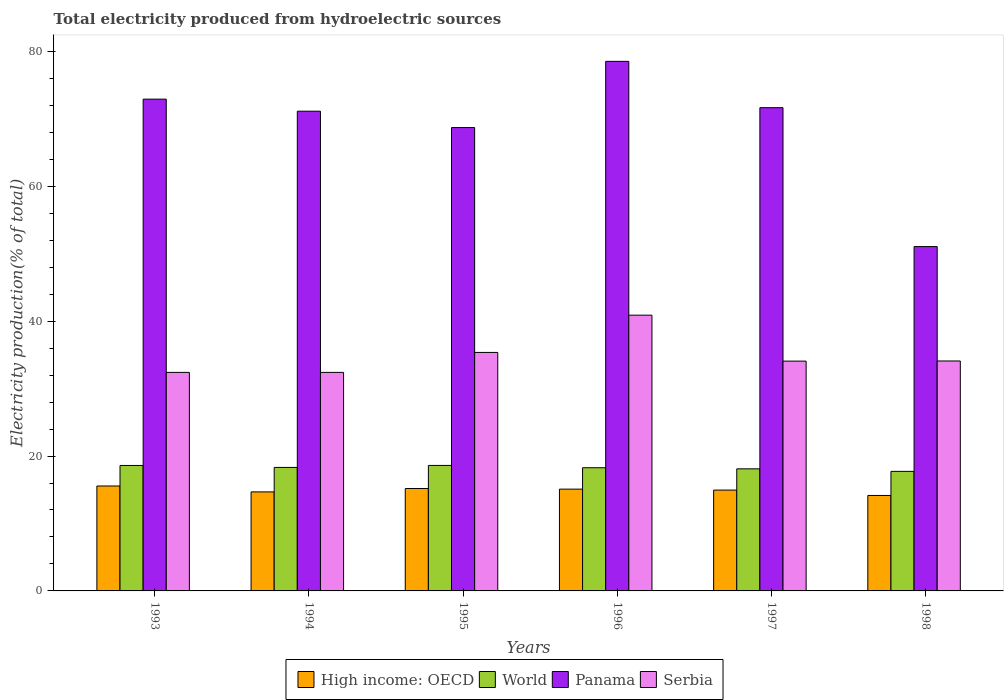How many different coloured bars are there?
Offer a terse response. 4. How many groups of bars are there?
Provide a short and direct response. 6. Are the number of bars per tick equal to the number of legend labels?
Offer a very short reply. Yes. Are the number of bars on each tick of the X-axis equal?
Provide a succinct answer. Yes. What is the label of the 2nd group of bars from the left?
Give a very brief answer. 1994. In how many cases, is the number of bars for a given year not equal to the number of legend labels?
Your response must be concise. 0. What is the total electricity produced in High income: OECD in 1995?
Keep it short and to the point. 15.19. Across all years, what is the maximum total electricity produced in World?
Make the answer very short. 18.61. Across all years, what is the minimum total electricity produced in Panama?
Offer a terse response. 51.06. In which year was the total electricity produced in High income: OECD maximum?
Make the answer very short. 1993. What is the total total electricity produced in World in the graph?
Give a very brief answer. 109.63. What is the difference between the total electricity produced in Panama in 1995 and that in 1996?
Make the answer very short. -9.82. What is the difference between the total electricity produced in Panama in 1993 and the total electricity produced in World in 1998?
Provide a short and direct response. 55.2. What is the average total electricity produced in Serbia per year?
Make the answer very short. 34.88. In the year 1997, what is the difference between the total electricity produced in Panama and total electricity produced in World?
Keep it short and to the point. 53.56. What is the ratio of the total electricity produced in World in 1996 to that in 1997?
Keep it short and to the point. 1.01. What is the difference between the highest and the second highest total electricity produced in High income: OECD?
Keep it short and to the point. 0.37. What is the difference between the highest and the lowest total electricity produced in Serbia?
Offer a terse response. 8.48. What does the 4th bar from the left in 1994 represents?
Make the answer very short. Serbia. Are all the bars in the graph horizontal?
Offer a very short reply. No. What is the difference between two consecutive major ticks on the Y-axis?
Provide a succinct answer. 20. Are the values on the major ticks of Y-axis written in scientific E-notation?
Keep it short and to the point. No. Does the graph contain grids?
Keep it short and to the point. No. Where does the legend appear in the graph?
Offer a very short reply. Bottom center. How many legend labels are there?
Your response must be concise. 4. What is the title of the graph?
Provide a short and direct response. Total electricity produced from hydroelectric sources. Does "Maldives" appear as one of the legend labels in the graph?
Make the answer very short. No. What is the label or title of the Y-axis?
Provide a short and direct response. Electricity production(% of total). What is the Electricity production(% of total) in High income: OECD in 1993?
Provide a succinct answer. 15.56. What is the Electricity production(% of total) of World in 1993?
Ensure brevity in your answer.  18.6. What is the Electricity production(% of total) in Panama in 1993?
Give a very brief answer. 72.93. What is the Electricity production(% of total) of Serbia in 1993?
Your response must be concise. 32.41. What is the Electricity production(% of total) of High income: OECD in 1994?
Provide a succinct answer. 14.68. What is the Electricity production(% of total) in World in 1994?
Provide a succinct answer. 18.31. What is the Electricity production(% of total) of Panama in 1994?
Ensure brevity in your answer.  71.14. What is the Electricity production(% of total) of Serbia in 1994?
Your response must be concise. 32.41. What is the Electricity production(% of total) in High income: OECD in 1995?
Give a very brief answer. 15.19. What is the Electricity production(% of total) of World in 1995?
Provide a short and direct response. 18.61. What is the Electricity production(% of total) of Panama in 1995?
Keep it short and to the point. 68.71. What is the Electricity production(% of total) in Serbia in 1995?
Offer a very short reply. 35.37. What is the Electricity production(% of total) in High income: OECD in 1996?
Your response must be concise. 15.09. What is the Electricity production(% of total) of World in 1996?
Keep it short and to the point. 18.27. What is the Electricity production(% of total) in Panama in 1996?
Offer a very short reply. 78.53. What is the Electricity production(% of total) of Serbia in 1996?
Your answer should be compact. 40.89. What is the Electricity production(% of total) of High income: OECD in 1997?
Keep it short and to the point. 14.95. What is the Electricity production(% of total) of World in 1997?
Provide a succinct answer. 18.11. What is the Electricity production(% of total) in Panama in 1997?
Make the answer very short. 71.66. What is the Electricity production(% of total) in Serbia in 1997?
Provide a succinct answer. 34.08. What is the Electricity production(% of total) of High income: OECD in 1998?
Ensure brevity in your answer.  14.16. What is the Electricity production(% of total) of World in 1998?
Give a very brief answer. 17.73. What is the Electricity production(% of total) of Panama in 1998?
Provide a short and direct response. 51.06. What is the Electricity production(% of total) in Serbia in 1998?
Your response must be concise. 34.1. Across all years, what is the maximum Electricity production(% of total) of High income: OECD?
Ensure brevity in your answer.  15.56. Across all years, what is the maximum Electricity production(% of total) in World?
Your response must be concise. 18.61. Across all years, what is the maximum Electricity production(% of total) of Panama?
Offer a very short reply. 78.53. Across all years, what is the maximum Electricity production(% of total) of Serbia?
Your answer should be very brief. 40.89. Across all years, what is the minimum Electricity production(% of total) in High income: OECD?
Your answer should be compact. 14.16. Across all years, what is the minimum Electricity production(% of total) in World?
Keep it short and to the point. 17.73. Across all years, what is the minimum Electricity production(% of total) of Panama?
Make the answer very short. 51.06. Across all years, what is the minimum Electricity production(% of total) in Serbia?
Your answer should be compact. 32.41. What is the total Electricity production(% of total) in High income: OECD in the graph?
Ensure brevity in your answer.  89.63. What is the total Electricity production(% of total) of World in the graph?
Provide a succinct answer. 109.63. What is the total Electricity production(% of total) of Panama in the graph?
Keep it short and to the point. 414.03. What is the total Electricity production(% of total) of Serbia in the graph?
Provide a succinct answer. 209.25. What is the difference between the Electricity production(% of total) in High income: OECD in 1993 and that in 1994?
Offer a terse response. 0.88. What is the difference between the Electricity production(% of total) of World in 1993 and that in 1994?
Offer a terse response. 0.29. What is the difference between the Electricity production(% of total) in Panama in 1993 and that in 1994?
Your answer should be compact. 1.79. What is the difference between the Electricity production(% of total) in High income: OECD in 1993 and that in 1995?
Offer a terse response. 0.37. What is the difference between the Electricity production(% of total) of World in 1993 and that in 1995?
Provide a succinct answer. -0. What is the difference between the Electricity production(% of total) of Panama in 1993 and that in 1995?
Your answer should be very brief. 4.21. What is the difference between the Electricity production(% of total) in Serbia in 1993 and that in 1995?
Provide a short and direct response. -2.96. What is the difference between the Electricity production(% of total) of High income: OECD in 1993 and that in 1996?
Your answer should be very brief. 0.47. What is the difference between the Electricity production(% of total) in World in 1993 and that in 1996?
Provide a short and direct response. 0.34. What is the difference between the Electricity production(% of total) in Panama in 1993 and that in 1996?
Your answer should be very brief. -5.6. What is the difference between the Electricity production(% of total) in Serbia in 1993 and that in 1996?
Keep it short and to the point. -8.48. What is the difference between the Electricity production(% of total) in High income: OECD in 1993 and that in 1997?
Keep it short and to the point. 0.61. What is the difference between the Electricity production(% of total) of World in 1993 and that in 1997?
Provide a succinct answer. 0.5. What is the difference between the Electricity production(% of total) in Panama in 1993 and that in 1997?
Offer a terse response. 1.27. What is the difference between the Electricity production(% of total) in Serbia in 1993 and that in 1997?
Provide a short and direct response. -1.67. What is the difference between the Electricity production(% of total) in High income: OECD in 1993 and that in 1998?
Your answer should be very brief. 1.4. What is the difference between the Electricity production(% of total) of World in 1993 and that in 1998?
Your response must be concise. 0.88. What is the difference between the Electricity production(% of total) of Panama in 1993 and that in 1998?
Give a very brief answer. 21.86. What is the difference between the Electricity production(% of total) in Serbia in 1993 and that in 1998?
Your answer should be very brief. -1.69. What is the difference between the Electricity production(% of total) of High income: OECD in 1994 and that in 1995?
Offer a very short reply. -0.5. What is the difference between the Electricity production(% of total) in World in 1994 and that in 1995?
Provide a succinct answer. -0.3. What is the difference between the Electricity production(% of total) in Panama in 1994 and that in 1995?
Make the answer very short. 2.43. What is the difference between the Electricity production(% of total) of Serbia in 1994 and that in 1995?
Provide a succinct answer. -2.96. What is the difference between the Electricity production(% of total) in High income: OECD in 1994 and that in 1996?
Offer a very short reply. -0.41. What is the difference between the Electricity production(% of total) of World in 1994 and that in 1996?
Your answer should be compact. 0.05. What is the difference between the Electricity production(% of total) of Panama in 1994 and that in 1996?
Ensure brevity in your answer.  -7.39. What is the difference between the Electricity production(% of total) in Serbia in 1994 and that in 1996?
Offer a very short reply. -8.48. What is the difference between the Electricity production(% of total) of High income: OECD in 1994 and that in 1997?
Ensure brevity in your answer.  -0.27. What is the difference between the Electricity production(% of total) in World in 1994 and that in 1997?
Your answer should be compact. 0.21. What is the difference between the Electricity production(% of total) in Panama in 1994 and that in 1997?
Your answer should be compact. -0.52. What is the difference between the Electricity production(% of total) of Serbia in 1994 and that in 1997?
Ensure brevity in your answer.  -1.67. What is the difference between the Electricity production(% of total) of High income: OECD in 1994 and that in 1998?
Your response must be concise. 0.53. What is the difference between the Electricity production(% of total) in World in 1994 and that in 1998?
Provide a succinct answer. 0.58. What is the difference between the Electricity production(% of total) of Panama in 1994 and that in 1998?
Your response must be concise. 20.08. What is the difference between the Electricity production(% of total) in Serbia in 1994 and that in 1998?
Offer a very short reply. -1.69. What is the difference between the Electricity production(% of total) of High income: OECD in 1995 and that in 1996?
Your answer should be compact. 0.09. What is the difference between the Electricity production(% of total) of World in 1995 and that in 1996?
Offer a terse response. 0.34. What is the difference between the Electricity production(% of total) in Panama in 1995 and that in 1996?
Provide a short and direct response. -9.82. What is the difference between the Electricity production(% of total) in Serbia in 1995 and that in 1996?
Ensure brevity in your answer.  -5.53. What is the difference between the Electricity production(% of total) in High income: OECD in 1995 and that in 1997?
Provide a succinct answer. 0.23. What is the difference between the Electricity production(% of total) of World in 1995 and that in 1997?
Provide a succinct answer. 0.5. What is the difference between the Electricity production(% of total) of Panama in 1995 and that in 1997?
Keep it short and to the point. -2.95. What is the difference between the Electricity production(% of total) of Serbia in 1995 and that in 1997?
Ensure brevity in your answer.  1.29. What is the difference between the Electricity production(% of total) in High income: OECD in 1995 and that in 1998?
Keep it short and to the point. 1.03. What is the difference between the Electricity production(% of total) in World in 1995 and that in 1998?
Keep it short and to the point. 0.88. What is the difference between the Electricity production(% of total) of Panama in 1995 and that in 1998?
Offer a very short reply. 17.65. What is the difference between the Electricity production(% of total) of Serbia in 1995 and that in 1998?
Make the answer very short. 1.27. What is the difference between the Electricity production(% of total) of High income: OECD in 1996 and that in 1997?
Keep it short and to the point. 0.14. What is the difference between the Electricity production(% of total) in World in 1996 and that in 1997?
Keep it short and to the point. 0.16. What is the difference between the Electricity production(% of total) in Panama in 1996 and that in 1997?
Offer a very short reply. 6.87. What is the difference between the Electricity production(% of total) of Serbia in 1996 and that in 1997?
Keep it short and to the point. 6.81. What is the difference between the Electricity production(% of total) in High income: OECD in 1996 and that in 1998?
Provide a succinct answer. 0.94. What is the difference between the Electricity production(% of total) in World in 1996 and that in 1998?
Keep it short and to the point. 0.54. What is the difference between the Electricity production(% of total) of Panama in 1996 and that in 1998?
Give a very brief answer. 27.47. What is the difference between the Electricity production(% of total) in Serbia in 1996 and that in 1998?
Your answer should be compact. 6.79. What is the difference between the Electricity production(% of total) of High income: OECD in 1997 and that in 1998?
Ensure brevity in your answer.  0.8. What is the difference between the Electricity production(% of total) of World in 1997 and that in 1998?
Your answer should be compact. 0.38. What is the difference between the Electricity production(% of total) of Panama in 1997 and that in 1998?
Your answer should be very brief. 20.6. What is the difference between the Electricity production(% of total) of Serbia in 1997 and that in 1998?
Provide a short and direct response. -0.02. What is the difference between the Electricity production(% of total) in High income: OECD in 1993 and the Electricity production(% of total) in World in 1994?
Keep it short and to the point. -2.75. What is the difference between the Electricity production(% of total) of High income: OECD in 1993 and the Electricity production(% of total) of Panama in 1994?
Offer a very short reply. -55.58. What is the difference between the Electricity production(% of total) of High income: OECD in 1993 and the Electricity production(% of total) of Serbia in 1994?
Provide a succinct answer. -16.85. What is the difference between the Electricity production(% of total) of World in 1993 and the Electricity production(% of total) of Panama in 1994?
Ensure brevity in your answer.  -52.53. What is the difference between the Electricity production(% of total) of World in 1993 and the Electricity production(% of total) of Serbia in 1994?
Ensure brevity in your answer.  -13.8. What is the difference between the Electricity production(% of total) in Panama in 1993 and the Electricity production(% of total) in Serbia in 1994?
Keep it short and to the point. 40.52. What is the difference between the Electricity production(% of total) of High income: OECD in 1993 and the Electricity production(% of total) of World in 1995?
Ensure brevity in your answer.  -3.05. What is the difference between the Electricity production(% of total) in High income: OECD in 1993 and the Electricity production(% of total) in Panama in 1995?
Ensure brevity in your answer.  -53.15. What is the difference between the Electricity production(% of total) of High income: OECD in 1993 and the Electricity production(% of total) of Serbia in 1995?
Offer a terse response. -19.81. What is the difference between the Electricity production(% of total) in World in 1993 and the Electricity production(% of total) in Panama in 1995?
Ensure brevity in your answer.  -50.11. What is the difference between the Electricity production(% of total) of World in 1993 and the Electricity production(% of total) of Serbia in 1995?
Ensure brevity in your answer.  -16.76. What is the difference between the Electricity production(% of total) of Panama in 1993 and the Electricity production(% of total) of Serbia in 1995?
Provide a succinct answer. 37.56. What is the difference between the Electricity production(% of total) in High income: OECD in 1993 and the Electricity production(% of total) in World in 1996?
Make the answer very short. -2.71. What is the difference between the Electricity production(% of total) of High income: OECD in 1993 and the Electricity production(% of total) of Panama in 1996?
Your answer should be compact. -62.97. What is the difference between the Electricity production(% of total) in High income: OECD in 1993 and the Electricity production(% of total) in Serbia in 1996?
Offer a very short reply. -25.33. What is the difference between the Electricity production(% of total) in World in 1993 and the Electricity production(% of total) in Panama in 1996?
Make the answer very short. -59.93. What is the difference between the Electricity production(% of total) of World in 1993 and the Electricity production(% of total) of Serbia in 1996?
Your answer should be very brief. -22.29. What is the difference between the Electricity production(% of total) of Panama in 1993 and the Electricity production(% of total) of Serbia in 1996?
Your answer should be very brief. 32.03. What is the difference between the Electricity production(% of total) in High income: OECD in 1993 and the Electricity production(% of total) in World in 1997?
Provide a succinct answer. -2.54. What is the difference between the Electricity production(% of total) of High income: OECD in 1993 and the Electricity production(% of total) of Panama in 1997?
Provide a short and direct response. -56.1. What is the difference between the Electricity production(% of total) in High income: OECD in 1993 and the Electricity production(% of total) in Serbia in 1997?
Give a very brief answer. -18.52. What is the difference between the Electricity production(% of total) in World in 1993 and the Electricity production(% of total) in Panama in 1997?
Offer a very short reply. -53.06. What is the difference between the Electricity production(% of total) of World in 1993 and the Electricity production(% of total) of Serbia in 1997?
Provide a short and direct response. -15.47. What is the difference between the Electricity production(% of total) of Panama in 1993 and the Electricity production(% of total) of Serbia in 1997?
Provide a succinct answer. 38.85. What is the difference between the Electricity production(% of total) of High income: OECD in 1993 and the Electricity production(% of total) of World in 1998?
Provide a succinct answer. -2.17. What is the difference between the Electricity production(% of total) of High income: OECD in 1993 and the Electricity production(% of total) of Panama in 1998?
Keep it short and to the point. -35.5. What is the difference between the Electricity production(% of total) of High income: OECD in 1993 and the Electricity production(% of total) of Serbia in 1998?
Keep it short and to the point. -18.54. What is the difference between the Electricity production(% of total) of World in 1993 and the Electricity production(% of total) of Panama in 1998?
Your answer should be compact. -32.46. What is the difference between the Electricity production(% of total) of World in 1993 and the Electricity production(% of total) of Serbia in 1998?
Provide a short and direct response. -15.49. What is the difference between the Electricity production(% of total) in Panama in 1993 and the Electricity production(% of total) in Serbia in 1998?
Your answer should be compact. 38.83. What is the difference between the Electricity production(% of total) of High income: OECD in 1994 and the Electricity production(% of total) of World in 1995?
Provide a succinct answer. -3.93. What is the difference between the Electricity production(% of total) in High income: OECD in 1994 and the Electricity production(% of total) in Panama in 1995?
Your answer should be very brief. -54.03. What is the difference between the Electricity production(% of total) of High income: OECD in 1994 and the Electricity production(% of total) of Serbia in 1995?
Your answer should be very brief. -20.68. What is the difference between the Electricity production(% of total) in World in 1994 and the Electricity production(% of total) in Panama in 1995?
Provide a short and direct response. -50.4. What is the difference between the Electricity production(% of total) of World in 1994 and the Electricity production(% of total) of Serbia in 1995?
Provide a short and direct response. -17.05. What is the difference between the Electricity production(% of total) in Panama in 1994 and the Electricity production(% of total) in Serbia in 1995?
Your answer should be very brief. 35.77. What is the difference between the Electricity production(% of total) in High income: OECD in 1994 and the Electricity production(% of total) in World in 1996?
Make the answer very short. -3.58. What is the difference between the Electricity production(% of total) in High income: OECD in 1994 and the Electricity production(% of total) in Panama in 1996?
Your answer should be compact. -63.85. What is the difference between the Electricity production(% of total) of High income: OECD in 1994 and the Electricity production(% of total) of Serbia in 1996?
Give a very brief answer. -26.21. What is the difference between the Electricity production(% of total) in World in 1994 and the Electricity production(% of total) in Panama in 1996?
Provide a succinct answer. -60.22. What is the difference between the Electricity production(% of total) in World in 1994 and the Electricity production(% of total) in Serbia in 1996?
Your response must be concise. -22.58. What is the difference between the Electricity production(% of total) in Panama in 1994 and the Electricity production(% of total) in Serbia in 1996?
Give a very brief answer. 30.25. What is the difference between the Electricity production(% of total) of High income: OECD in 1994 and the Electricity production(% of total) of World in 1997?
Keep it short and to the point. -3.42. What is the difference between the Electricity production(% of total) in High income: OECD in 1994 and the Electricity production(% of total) in Panama in 1997?
Your response must be concise. -56.98. What is the difference between the Electricity production(% of total) in High income: OECD in 1994 and the Electricity production(% of total) in Serbia in 1997?
Make the answer very short. -19.4. What is the difference between the Electricity production(% of total) in World in 1994 and the Electricity production(% of total) in Panama in 1997?
Provide a short and direct response. -53.35. What is the difference between the Electricity production(% of total) of World in 1994 and the Electricity production(% of total) of Serbia in 1997?
Provide a short and direct response. -15.77. What is the difference between the Electricity production(% of total) of Panama in 1994 and the Electricity production(% of total) of Serbia in 1997?
Your answer should be very brief. 37.06. What is the difference between the Electricity production(% of total) of High income: OECD in 1994 and the Electricity production(% of total) of World in 1998?
Make the answer very short. -3.05. What is the difference between the Electricity production(% of total) in High income: OECD in 1994 and the Electricity production(% of total) in Panama in 1998?
Your answer should be compact. -36.38. What is the difference between the Electricity production(% of total) in High income: OECD in 1994 and the Electricity production(% of total) in Serbia in 1998?
Your answer should be compact. -19.42. What is the difference between the Electricity production(% of total) of World in 1994 and the Electricity production(% of total) of Panama in 1998?
Make the answer very short. -32.75. What is the difference between the Electricity production(% of total) in World in 1994 and the Electricity production(% of total) in Serbia in 1998?
Offer a terse response. -15.79. What is the difference between the Electricity production(% of total) of Panama in 1994 and the Electricity production(% of total) of Serbia in 1998?
Make the answer very short. 37.04. What is the difference between the Electricity production(% of total) of High income: OECD in 1995 and the Electricity production(% of total) of World in 1996?
Ensure brevity in your answer.  -3.08. What is the difference between the Electricity production(% of total) in High income: OECD in 1995 and the Electricity production(% of total) in Panama in 1996?
Offer a terse response. -63.34. What is the difference between the Electricity production(% of total) in High income: OECD in 1995 and the Electricity production(% of total) in Serbia in 1996?
Ensure brevity in your answer.  -25.71. What is the difference between the Electricity production(% of total) of World in 1995 and the Electricity production(% of total) of Panama in 1996?
Offer a very short reply. -59.92. What is the difference between the Electricity production(% of total) in World in 1995 and the Electricity production(% of total) in Serbia in 1996?
Make the answer very short. -22.28. What is the difference between the Electricity production(% of total) in Panama in 1995 and the Electricity production(% of total) in Serbia in 1996?
Offer a terse response. 27.82. What is the difference between the Electricity production(% of total) in High income: OECD in 1995 and the Electricity production(% of total) in World in 1997?
Keep it short and to the point. -2.92. What is the difference between the Electricity production(% of total) in High income: OECD in 1995 and the Electricity production(% of total) in Panama in 1997?
Your response must be concise. -56.48. What is the difference between the Electricity production(% of total) of High income: OECD in 1995 and the Electricity production(% of total) of Serbia in 1997?
Your answer should be very brief. -18.89. What is the difference between the Electricity production(% of total) in World in 1995 and the Electricity production(% of total) in Panama in 1997?
Provide a short and direct response. -53.05. What is the difference between the Electricity production(% of total) in World in 1995 and the Electricity production(% of total) in Serbia in 1997?
Your response must be concise. -15.47. What is the difference between the Electricity production(% of total) of Panama in 1995 and the Electricity production(% of total) of Serbia in 1997?
Provide a short and direct response. 34.63. What is the difference between the Electricity production(% of total) in High income: OECD in 1995 and the Electricity production(% of total) in World in 1998?
Ensure brevity in your answer.  -2.54. What is the difference between the Electricity production(% of total) of High income: OECD in 1995 and the Electricity production(% of total) of Panama in 1998?
Offer a very short reply. -35.88. What is the difference between the Electricity production(% of total) of High income: OECD in 1995 and the Electricity production(% of total) of Serbia in 1998?
Your response must be concise. -18.91. What is the difference between the Electricity production(% of total) of World in 1995 and the Electricity production(% of total) of Panama in 1998?
Provide a short and direct response. -32.45. What is the difference between the Electricity production(% of total) in World in 1995 and the Electricity production(% of total) in Serbia in 1998?
Give a very brief answer. -15.49. What is the difference between the Electricity production(% of total) of Panama in 1995 and the Electricity production(% of total) of Serbia in 1998?
Make the answer very short. 34.61. What is the difference between the Electricity production(% of total) in High income: OECD in 1996 and the Electricity production(% of total) in World in 1997?
Give a very brief answer. -3.01. What is the difference between the Electricity production(% of total) in High income: OECD in 1996 and the Electricity production(% of total) in Panama in 1997?
Offer a terse response. -56.57. What is the difference between the Electricity production(% of total) of High income: OECD in 1996 and the Electricity production(% of total) of Serbia in 1997?
Provide a short and direct response. -18.98. What is the difference between the Electricity production(% of total) in World in 1996 and the Electricity production(% of total) in Panama in 1997?
Your answer should be very brief. -53.39. What is the difference between the Electricity production(% of total) in World in 1996 and the Electricity production(% of total) in Serbia in 1997?
Ensure brevity in your answer.  -15.81. What is the difference between the Electricity production(% of total) of Panama in 1996 and the Electricity production(% of total) of Serbia in 1997?
Make the answer very short. 44.45. What is the difference between the Electricity production(% of total) of High income: OECD in 1996 and the Electricity production(% of total) of World in 1998?
Make the answer very short. -2.64. What is the difference between the Electricity production(% of total) in High income: OECD in 1996 and the Electricity production(% of total) in Panama in 1998?
Make the answer very short. -35.97. What is the difference between the Electricity production(% of total) in High income: OECD in 1996 and the Electricity production(% of total) in Serbia in 1998?
Keep it short and to the point. -19. What is the difference between the Electricity production(% of total) in World in 1996 and the Electricity production(% of total) in Panama in 1998?
Ensure brevity in your answer.  -32.79. What is the difference between the Electricity production(% of total) in World in 1996 and the Electricity production(% of total) in Serbia in 1998?
Your answer should be very brief. -15.83. What is the difference between the Electricity production(% of total) of Panama in 1996 and the Electricity production(% of total) of Serbia in 1998?
Provide a succinct answer. 44.43. What is the difference between the Electricity production(% of total) in High income: OECD in 1997 and the Electricity production(% of total) in World in 1998?
Offer a very short reply. -2.78. What is the difference between the Electricity production(% of total) of High income: OECD in 1997 and the Electricity production(% of total) of Panama in 1998?
Offer a very short reply. -36.11. What is the difference between the Electricity production(% of total) in High income: OECD in 1997 and the Electricity production(% of total) in Serbia in 1998?
Your response must be concise. -19.15. What is the difference between the Electricity production(% of total) of World in 1997 and the Electricity production(% of total) of Panama in 1998?
Give a very brief answer. -32.96. What is the difference between the Electricity production(% of total) in World in 1997 and the Electricity production(% of total) in Serbia in 1998?
Offer a terse response. -15.99. What is the difference between the Electricity production(% of total) in Panama in 1997 and the Electricity production(% of total) in Serbia in 1998?
Offer a very short reply. 37.56. What is the average Electricity production(% of total) in High income: OECD per year?
Provide a short and direct response. 14.94. What is the average Electricity production(% of total) of World per year?
Give a very brief answer. 18.27. What is the average Electricity production(% of total) in Panama per year?
Your answer should be compact. 69.01. What is the average Electricity production(% of total) in Serbia per year?
Ensure brevity in your answer.  34.88. In the year 1993, what is the difference between the Electricity production(% of total) in High income: OECD and Electricity production(% of total) in World?
Give a very brief answer. -3.04. In the year 1993, what is the difference between the Electricity production(% of total) of High income: OECD and Electricity production(% of total) of Panama?
Make the answer very short. -57.37. In the year 1993, what is the difference between the Electricity production(% of total) in High income: OECD and Electricity production(% of total) in Serbia?
Ensure brevity in your answer.  -16.85. In the year 1993, what is the difference between the Electricity production(% of total) of World and Electricity production(% of total) of Panama?
Provide a short and direct response. -54.32. In the year 1993, what is the difference between the Electricity production(% of total) of World and Electricity production(% of total) of Serbia?
Ensure brevity in your answer.  -13.8. In the year 1993, what is the difference between the Electricity production(% of total) of Panama and Electricity production(% of total) of Serbia?
Offer a terse response. 40.52. In the year 1994, what is the difference between the Electricity production(% of total) in High income: OECD and Electricity production(% of total) in World?
Your answer should be very brief. -3.63. In the year 1994, what is the difference between the Electricity production(% of total) of High income: OECD and Electricity production(% of total) of Panama?
Give a very brief answer. -56.46. In the year 1994, what is the difference between the Electricity production(% of total) in High income: OECD and Electricity production(% of total) in Serbia?
Your response must be concise. -17.72. In the year 1994, what is the difference between the Electricity production(% of total) in World and Electricity production(% of total) in Panama?
Provide a short and direct response. -52.83. In the year 1994, what is the difference between the Electricity production(% of total) of World and Electricity production(% of total) of Serbia?
Give a very brief answer. -14.09. In the year 1994, what is the difference between the Electricity production(% of total) in Panama and Electricity production(% of total) in Serbia?
Make the answer very short. 38.73. In the year 1995, what is the difference between the Electricity production(% of total) in High income: OECD and Electricity production(% of total) in World?
Your answer should be very brief. -3.42. In the year 1995, what is the difference between the Electricity production(% of total) of High income: OECD and Electricity production(% of total) of Panama?
Your answer should be compact. -53.53. In the year 1995, what is the difference between the Electricity production(% of total) in High income: OECD and Electricity production(% of total) in Serbia?
Make the answer very short. -20.18. In the year 1995, what is the difference between the Electricity production(% of total) of World and Electricity production(% of total) of Panama?
Your answer should be very brief. -50.1. In the year 1995, what is the difference between the Electricity production(% of total) of World and Electricity production(% of total) of Serbia?
Provide a succinct answer. -16.76. In the year 1995, what is the difference between the Electricity production(% of total) in Panama and Electricity production(% of total) in Serbia?
Make the answer very short. 33.35. In the year 1996, what is the difference between the Electricity production(% of total) in High income: OECD and Electricity production(% of total) in World?
Your answer should be very brief. -3.17. In the year 1996, what is the difference between the Electricity production(% of total) in High income: OECD and Electricity production(% of total) in Panama?
Offer a very short reply. -63.44. In the year 1996, what is the difference between the Electricity production(% of total) of High income: OECD and Electricity production(% of total) of Serbia?
Offer a terse response. -25.8. In the year 1996, what is the difference between the Electricity production(% of total) in World and Electricity production(% of total) in Panama?
Give a very brief answer. -60.26. In the year 1996, what is the difference between the Electricity production(% of total) in World and Electricity production(% of total) in Serbia?
Provide a succinct answer. -22.63. In the year 1996, what is the difference between the Electricity production(% of total) of Panama and Electricity production(% of total) of Serbia?
Offer a terse response. 37.64. In the year 1997, what is the difference between the Electricity production(% of total) in High income: OECD and Electricity production(% of total) in World?
Ensure brevity in your answer.  -3.15. In the year 1997, what is the difference between the Electricity production(% of total) of High income: OECD and Electricity production(% of total) of Panama?
Ensure brevity in your answer.  -56.71. In the year 1997, what is the difference between the Electricity production(% of total) of High income: OECD and Electricity production(% of total) of Serbia?
Make the answer very short. -19.13. In the year 1997, what is the difference between the Electricity production(% of total) of World and Electricity production(% of total) of Panama?
Offer a terse response. -53.56. In the year 1997, what is the difference between the Electricity production(% of total) in World and Electricity production(% of total) in Serbia?
Provide a succinct answer. -15.97. In the year 1997, what is the difference between the Electricity production(% of total) in Panama and Electricity production(% of total) in Serbia?
Offer a terse response. 37.58. In the year 1998, what is the difference between the Electricity production(% of total) in High income: OECD and Electricity production(% of total) in World?
Offer a very short reply. -3.57. In the year 1998, what is the difference between the Electricity production(% of total) in High income: OECD and Electricity production(% of total) in Panama?
Your response must be concise. -36.91. In the year 1998, what is the difference between the Electricity production(% of total) of High income: OECD and Electricity production(% of total) of Serbia?
Make the answer very short. -19.94. In the year 1998, what is the difference between the Electricity production(% of total) of World and Electricity production(% of total) of Panama?
Give a very brief answer. -33.33. In the year 1998, what is the difference between the Electricity production(% of total) of World and Electricity production(% of total) of Serbia?
Offer a very short reply. -16.37. In the year 1998, what is the difference between the Electricity production(% of total) in Panama and Electricity production(% of total) in Serbia?
Make the answer very short. 16.96. What is the ratio of the Electricity production(% of total) of High income: OECD in 1993 to that in 1994?
Your answer should be compact. 1.06. What is the ratio of the Electricity production(% of total) of World in 1993 to that in 1994?
Provide a succinct answer. 1.02. What is the ratio of the Electricity production(% of total) of Panama in 1993 to that in 1994?
Ensure brevity in your answer.  1.03. What is the ratio of the Electricity production(% of total) of Serbia in 1993 to that in 1994?
Offer a very short reply. 1. What is the ratio of the Electricity production(% of total) of High income: OECD in 1993 to that in 1995?
Offer a terse response. 1.02. What is the ratio of the Electricity production(% of total) of Panama in 1993 to that in 1995?
Provide a succinct answer. 1.06. What is the ratio of the Electricity production(% of total) of Serbia in 1993 to that in 1995?
Keep it short and to the point. 0.92. What is the ratio of the Electricity production(% of total) in High income: OECD in 1993 to that in 1996?
Keep it short and to the point. 1.03. What is the ratio of the Electricity production(% of total) of World in 1993 to that in 1996?
Offer a very short reply. 1.02. What is the ratio of the Electricity production(% of total) in Panama in 1993 to that in 1996?
Provide a short and direct response. 0.93. What is the ratio of the Electricity production(% of total) of Serbia in 1993 to that in 1996?
Provide a succinct answer. 0.79. What is the ratio of the Electricity production(% of total) of High income: OECD in 1993 to that in 1997?
Keep it short and to the point. 1.04. What is the ratio of the Electricity production(% of total) of World in 1993 to that in 1997?
Your answer should be very brief. 1.03. What is the ratio of the Electricity production(% of total) in Panama in 1993 to that in 1997?
Make the answer very short. 1.02. What is the ratio of the Electricity production(% of total) in Serbia in 1993 to that in 1997?
Provide a succinct answer. 0.95. What is the ratio of the Electricity production(% of total) of High income: OECD in 1993 to that in 1998?
Ensure brevity in your answer.  1.1. What is the ratio of the Electricity production(% of total) in World in 1993 to that in 1998?
Keep it short and to the point. 1.05. What is the ratio of the Electricity production(% of total) in Panama in 1993 to that in 1998?
Provide a short and direct response. 1.43. What is the ratio of the Electricity production(% of total) in Serbia in 1993 to that in 1998?
Offer a very short reply. 0.95. What is the ratio of the Electricity production(% of total) of High income: OECD in 1994 to that in 1995?
Provide a short and direct response. 0.97. What is the ratio of the Electricity production(% of total) of World in 1994 to that in 1995?
Your answer should be compact. 0.98. What is the ratio of the Electricity production(% of total) of Panama in 1994 to that in 1995?
Your response must be concise. 1.04. What is the ratio of the Electricity production(% of total) in Serbia in 1994 to that in 1995?
Make the answer very short. 0.92. What is the ratio of the Electricity production(% of total) in High income: OECD in 1994 to that in 1996?
Provide a succinct answer. 0.97. What is the ratio of the Electricity production(% of total) in World in 1994 to that in 1996?
Give a very brief answer. 1. What is the ratio of the Electricity production(% of total) in Panama in 1994 to that in 1996?
Make the answer very short. 0.91. What is the ratio of the Electricity production(% of total) in Serbia in 1994 to that in 1996?
Ensure brevity in your answer.  0.79. What is the ratio of the Electricity production(% of total) of High income: OECD in 1994 to that in 1997?
Provide a short and direct response. 0.98. What is the ratio of the Electricity production(% of total) of World in 1994 to that in 1997?
Make the answer very short. 1.01. What is the ratio of the Electricity production(% of total) in Panama in 1994 to that in 1997?
Provide a succinct answer. 0.99. What is the ratio of the Electricity production(% of total) in Serbia in 1994 to that in 1997?
Provide a succinct answer. 0.95. What is the ratio of the Electricity production(% of total) in High income: OECD in 1994 to that in 1998?
Ensure brevity in your answer.  1.04. What is the ratio of the Electricity production(% of total) in World in 1994 to that in 1998?
Offer a terse response. 1.03. What is the ratio of the Electricity production(% of total) of Panama in 1994 to that in 1998?
Offer a terse response. 1.39. What is the ratio of the Electricity production(% of total) in Serbia in 1994 to that in 1998?
Offer a very short reply. 0.95. What is the ratio of the Electricity production(% of total) in World in 1995 to that in 1996?
Your answer should be compact. 1.02. What is the ratio of the Electricity production(% of total) of Panama in 1995 to that in 1996?
Make the answer very short. 0.88. What is the ratio of the Electricity production(% of total) of Serbia in 1995 to that in 1996?
Provide a short and direct response. 0.86. What is the ratio of the Electricity production(% of total) of High income: OECD in 1995 to that in 1997?
Give a very brief answer. 1.02. What is the ratio of the Electricity production(% of total) of World in 1995 to that in 1997?
Offer a very short reply. 1.03. What is the ratio of the Electricity production(% of total) in Panama in 1995 to that in 1997?
Provide a short and direct response. 0.96. What is the ratio of the Electricity production(% of total) of Serbia in 1995 to that in 1997?
Provide a succinct answer. 1.04. What is the ratio of the Electricity production(% of total) of High income: OECD in 1995 to that in 1998?
Give a very brief answer. 1.07. What is the ratio of the Electricity production(% of total) of World in 1995 to that in 1998?
Offer a very short reply. 1.05. What is the ratio of the Electricity production(% of total) in Panama in 1995 to that in 1998?
Give a very brief answer. 1.35. What is the ratio of the Electricity production(% of total) in Serbia in 1995 to that in 1998?
Your answer should be very brief. 1.04. What is the ratio of the Electricity production(% of total) in High income: OECD in 1996 to that in 1997?
Give a very brief answer. 1.01. What is the ratio of the Electricity production(% of total) of World in 1996 to that in 1997?
Offer a very short reply. 1.01. What is the ratio of the Electricity production(% of total) in Panama in 1996 to that in 1997?
Provide a short and direct response. 1.1. What is the ratio of the Electricity production(% of total) in Serbia in 1996 to that in 1997?
Your answer should be very brief. 1.2. What is the ratio of the Electricity production(% of total) in High income: OECD in 1996 to that in 1998?
Make the answer very short. 1.07. What is the ratio of the Electricity production(% of total) of World in 1996 to that in 1998?
Make the answer very short. 1.03. What is the ratio of the Electricity production(% of total) in Panama in 1996 to that in 1998?
Provide a succinct answer. 1.54. What is the ratio of the Electricity production(% of total) in Serbia in 1996 to that in 1998?
Give a very brief answer. 1.2. What is the ratio of the Electricity production(% of total) in High income: OECD in 1997 to that in 1998?
Provide a succinct answer. 1.06. What is the ratio of the Electricity production(% of total) in World in 1997 to that in 1998?
Keep it short and to the point. 1.02. What is the ratio of the Electricity production(% of total) in Panama in 1997 to that in 1998?
Offer a terse response. 1.4. What is the difference between the highest and the second highest Electricity production(% of total) of High income: OECD?
Provide a succinct answer. 0.37. What is the difference between the highest and the second highest Electricity production(% of total) of World?
Offer a very short reply. 0. What is the difference between the highest and the second highest Electricity production(% of total) of Panama?
Provide a short and direct response. 5.6. What is the difference between the highest and the second highest Electricity production(% of total) of Serbia?
Your answer should be very brief. 5.53. What is the difference between the highest and the lowest Electricity production(% of total) in High income: OECD?
Offer a terse response. 1.4. What is the difference between the highest and the lowest Electricity production(% of total) of World?
Your answer should be compact. 0.88. What is the difference between the highest and the lowest Electricity production(% of total) of Panama?
Ensure brevity in your answer.  27.47. What is the difference between the highest and the lowest Electricity production(% of total) in Serbia?
Ensure brevity in your answer.  8.48. 